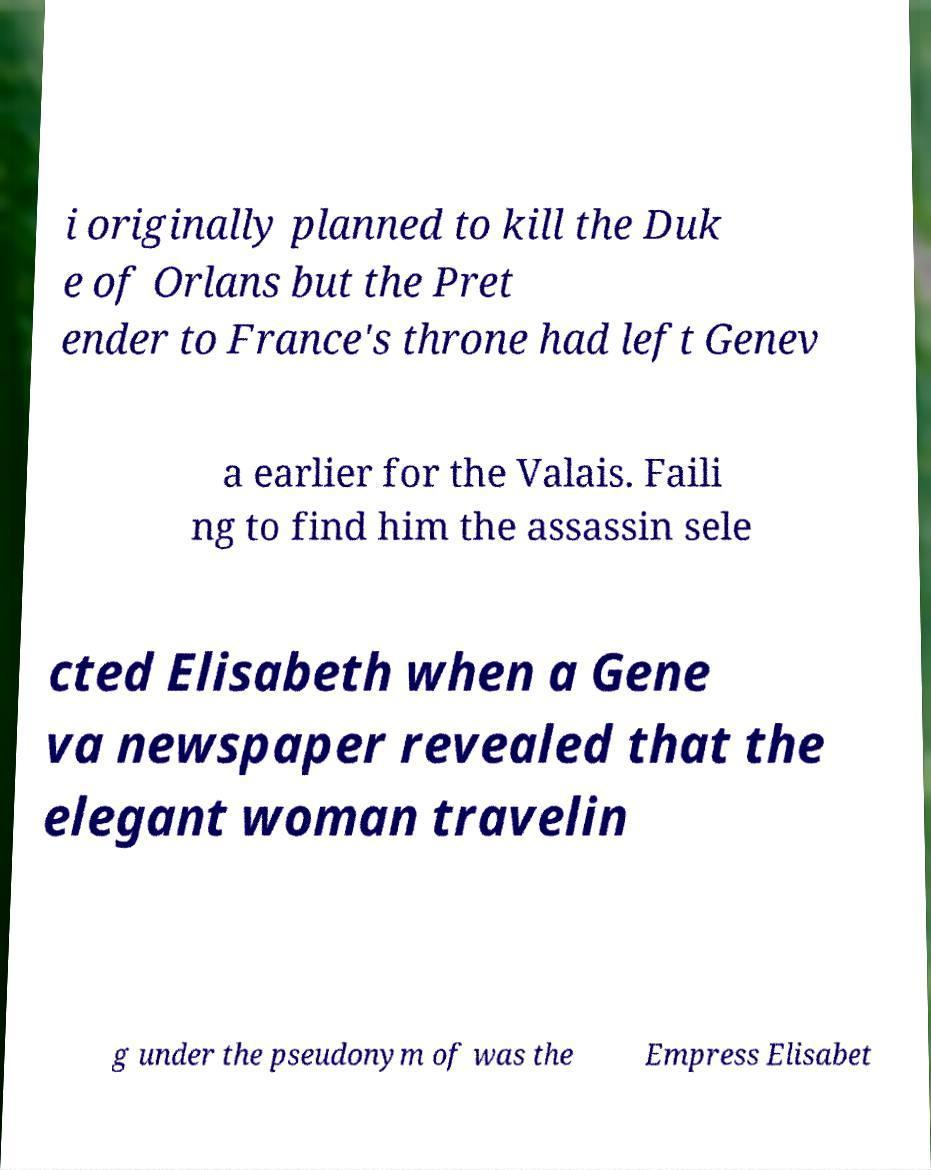What messages or text are displayed in this image? I need them in a readable, typed format. i originally planned to kill the Duk e of Orlans but the Pret ender to France's throne had left Genev a earlier for the Valais. Faili ng to find him the assassin sele cted Elisabeth when a Gene va newspaper revealed that the elegant woman travelin g under the pseudonym of was the Empress Elisabet 